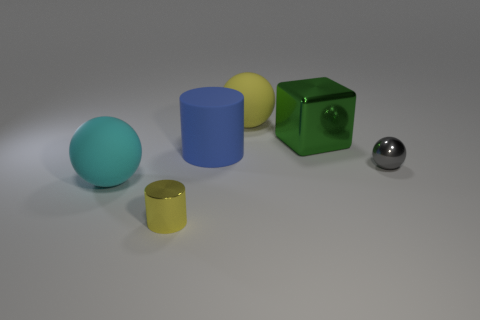There is another big thing that is the same shape as the big yellow object; what color is it?
Ensure brevity in your answer.  Cyan. What color is the other shiny object that is the same size as the blue object?
Your answer should be very brief. Green. Is the material of the blue thing the same as the large cyan sphere?
Keep it short and to the point. Yes. What number of big matte objects are the same color as the shiny block?
Offer a very short reply. 0. Do the small ball and the small shiny cylinder have the same color?
Provide a short and direct response. No. What is the small gray thing that is in front of the large metallic block made of?
Provide a succinct answer. Metal. What number of big objects are green cylinders or cyan objects?
Your answer should be compact. 1. There is a big thing that is the same color as the metallic cylinder; what is its material?
Keep it short and to the point. Rubber. Is there a gray ball made of the same material as the green object?
Your response must be concise. Yes. There is a cylinder in front of the gray object; does it have the same size as the yellow rubber thing?
Keep it short and to the point. No. 